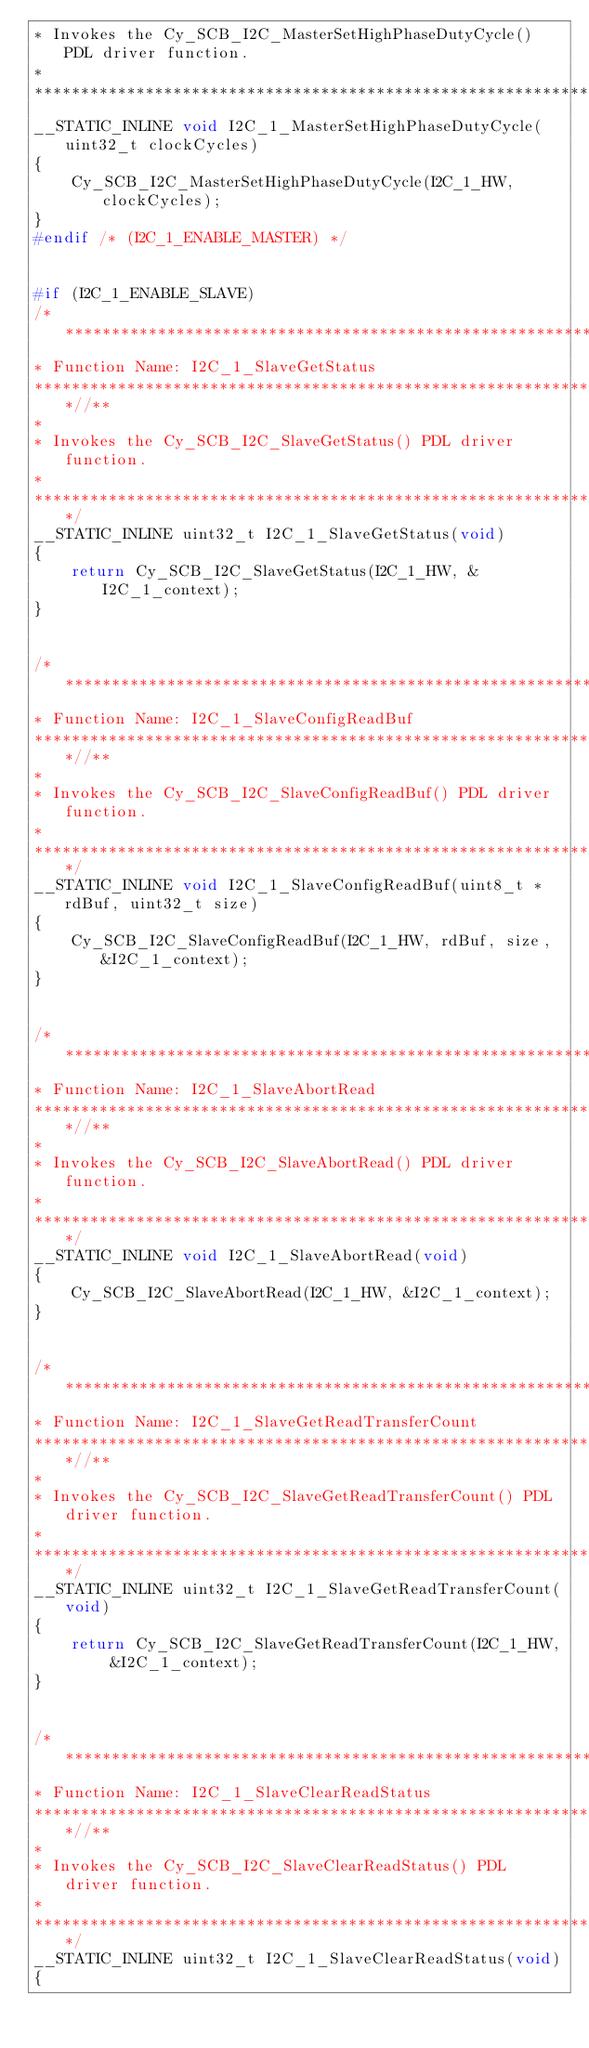<code> <loc_0><loc_0><loc_500><loc_500><_C_>* Invokes the Cy_SCB_I2C_MasterSetHighPhaseDutyCycle() PDL driver function.
*
*******************************************************************************/
__STATIC_INLINE void I2C_1_MasterSetHighPhaseDutyCycle(uint32_t clockCycles)
{
    Cy_SCB_I2C_MasterSetHighPhaseDutyCycle(I2C_1_HW, clockCycles);
}
#endif /* (I2C_1_ENABLE_MASTER) */


#if (I2C_1_ENABLE_SLAVE)
/*******************************************************************************
* Function Name: I2C_1_SlaveGetStatus
****************************************************************************//**
*
* Invokes the Cy_SCB_I2C_SlaveGetStatus() PDL driver function.
*
*******************************************************************************/
__STATIC_INLINE uint32_t I2C_1_SlaveGetStatus(void)
{
    return Cy_SCB_I2C_SlaveGetStatus(I2C_1_HW, &I2C_1_context);
}


/*******************************************************************************
* Function Name: I2C_1_SlaveConfigReadBuf
****************************************************************************//**
*
* Invokes the Cy_SCB_I2C_SlaveConfigReadBuf() PDL driver function.
*
*******************************************************************************/
__STATIC_INLINE void I2C_1_SlaveConfigReadBuf(uint8_t *rdBuf, uint32_t size)
{
    Cy_SCB_I2C_SlaveConfigReadBuf(I2C_1_HW, rdBuf, size, &I2C_1_context);
}


/*******************************************************************************
* Function Name: I2C_1_SlaveAbortRead
****************************************************************************//**
*
* Invokes the Cy_SCB_I2C_SlaveAbortRead() PDL driver function.
*
*******************************************************************************/
__STATIC_INLINE void I2C_1_SlaveAbortRead(void)
{
    Cy_SCB_I2C_SlaveAbortRead(I2C_1_HW, &I2C_1_context);
}


/*******************************************************************************
* Function Name: I2C_1_SlaveGetReadTransferCount
****************************************************************************//**
*
* Invokes the Cy_SCB_I2C_SlaveGetReadTransferCount() PDL driver function.
*
*******************************************************************************/
__STATIC_INLINE uint32_t I2C_1_SlaveGetReadTransferCount(void)
{
    return Cy_SCB_I2C_SlaveGetReadTransferCount(I2C_1_HW, &I2C_1_context);
}


/*******************************************************************************
* Function Name: I2C_1_SlaveClearReadStatus
****************************************************************************//**
*
* Invokes the Cy_SCB_I2C_SlaveClearReadStatus() PDL driver function.
*
*******************************************************************************/
__STATIC_INLINE uint32_t I2C_1_SlaveClearReadStatus(void)
{</code> 